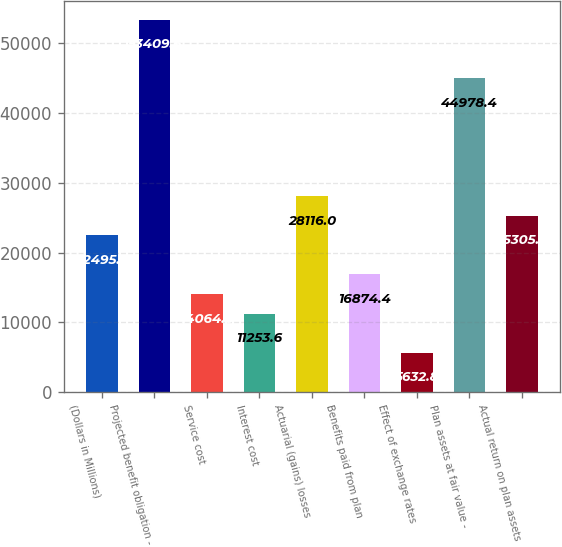Convert chart to OTSL. <chart><loc_0><loc_0><loc_500><loc_500><bar_chart><fcel>(Dollars in Millions)<fcel>Projected benefit obligation -<fcel>Service cost<fcel>Interest cost<fcel>Actuarial (gains) losses<fcel>Benefits paid from plan<fcel>Effect of exchange rates<fcel>Plan assets at fair value -<fcel>Actual return on plan assets<nl><fcel>22495.2<fcel>53409.6<fcel>14064<fcel>11253.6<fcel>28116<fcel>16874.4<fcel>5632.8<fcel>44978.4<fcel>25305.6<nl></chart> 